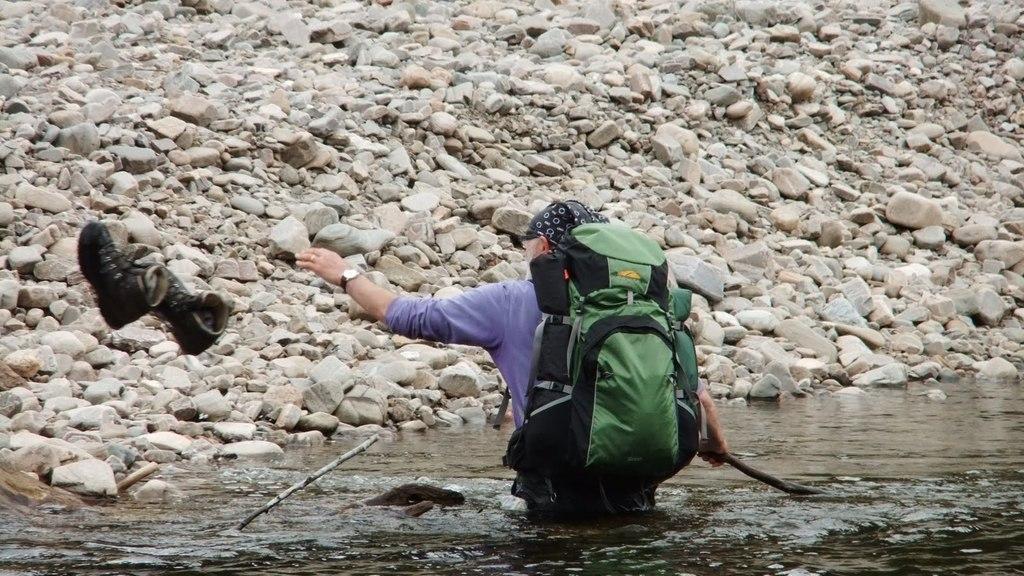Could you give a brief overview of what you see in this image? In this image we can see a person wearing bag and spectacles holding a stick in his hand is standing the water. To the left side of the image we can see two shoes. In the background ,we can see the stones. 